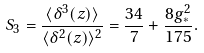Convert formula to latex. <formula><loc_0><loc_0><loc_500><loc_500>S _ { 3 } = \frac { \langle \delta ^ { 3 } ( z ) \rangle } { \langle \delta ^ { 2 } ( z ) \rangle ^ { 2 } } = \frac { 3 4 } { 7 } + \frac { 8 g _ { \ast } ^ { 2 } } { 1 7 5 } .</formula> 